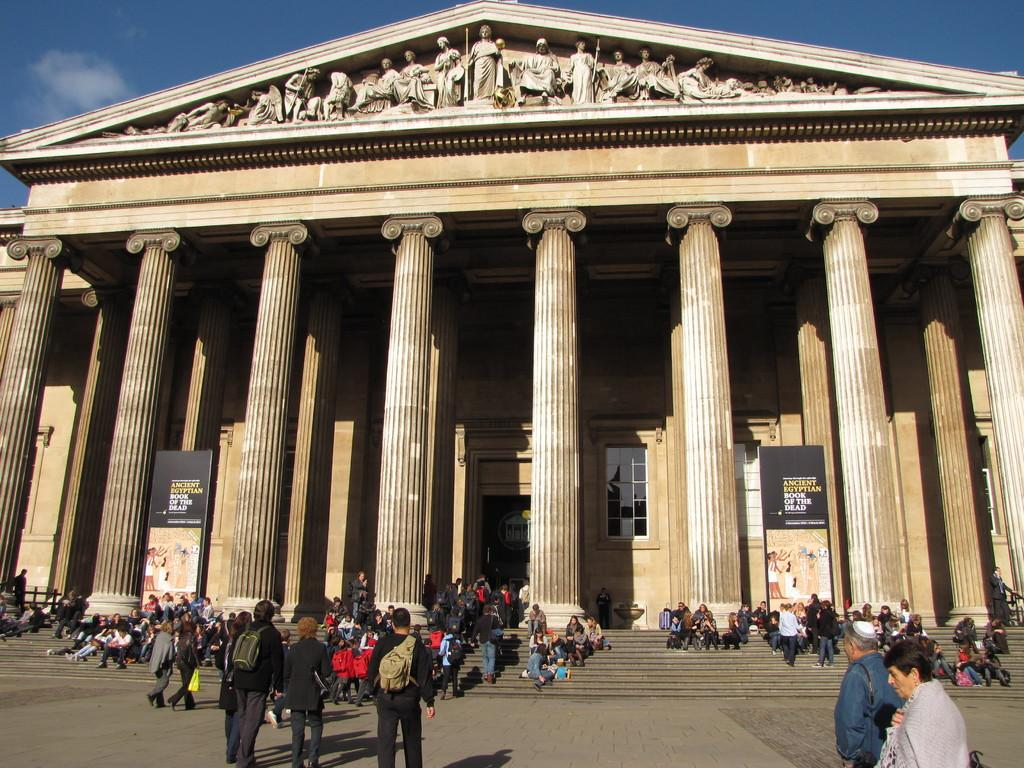<image>
Present a compact description of the photo's key features. A crowd of people are gathered outside a historical Greek building with a sign that says Ancient Egyptian Book of the Dead. 